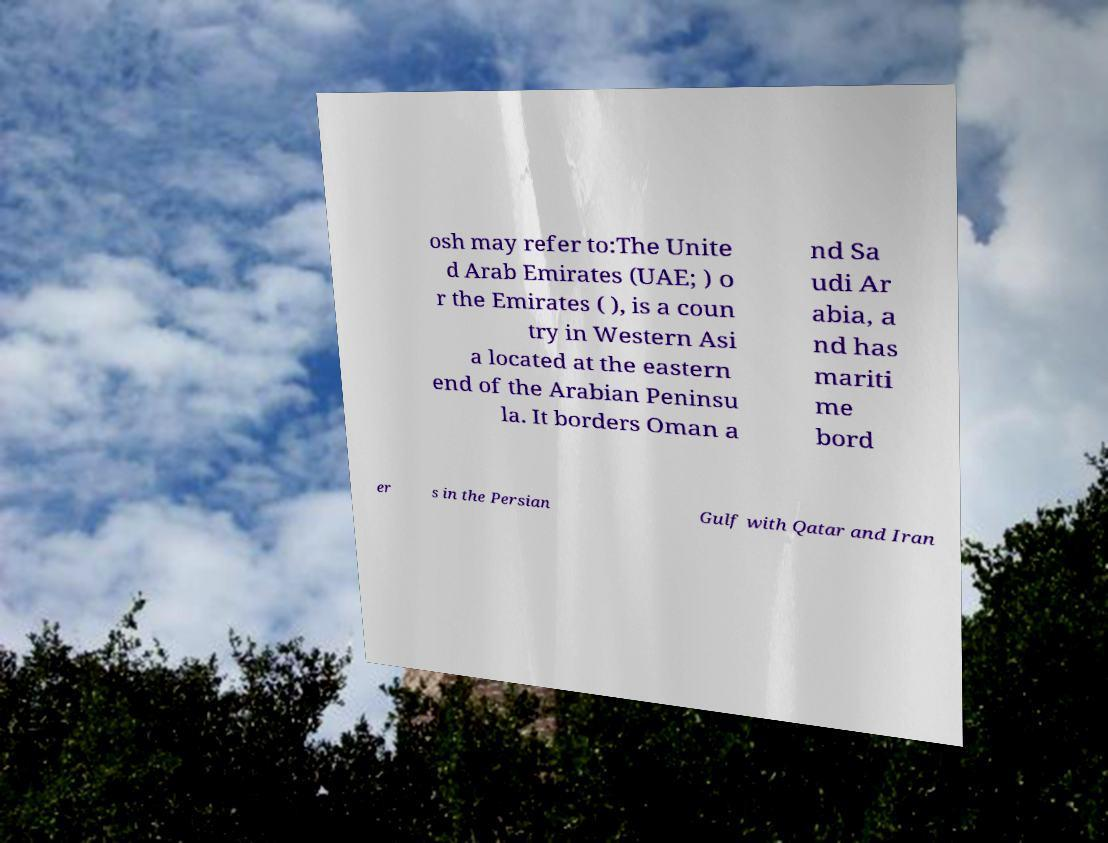Please read and relay the text visible in this image. What does it say? osh may refer to:The Unite d Arab Emirates (UAE; ) o r the Emirates ( ), is a coun try in Western Asi a located at the eastern end of the Arabian Peninsu la. It borders Oman a nd Sa udi Ar abia, a nd has mariti me bord er s in the Persian Gulf with Qatar and Iran 